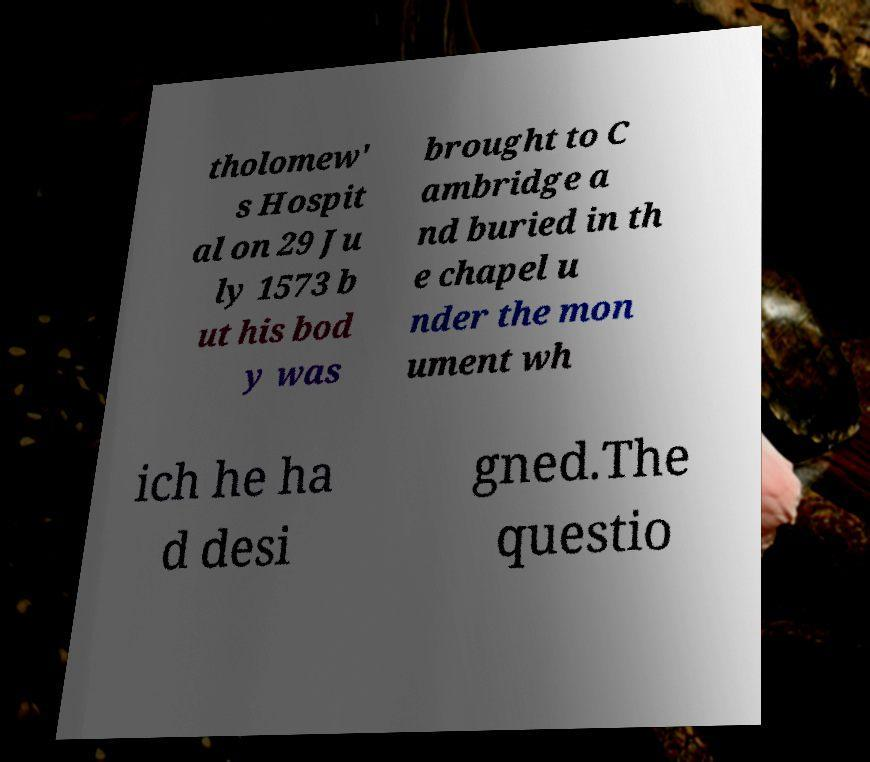Could you extract and type out the text from this image? tholomew' s Hospit al on 29 Ju ly 1573 b ut his bod y was brought to C ambridge a nd buried in th e chapel u nder the mon ument wh ich he ha d desi gned.The questio 